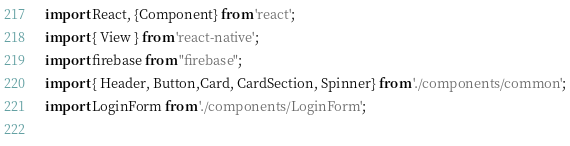<code> <loc_0><loc_0><loc_500><loc_500><_JavaScript_>import React, {Component} from 'react';
import { View } from 'react-native';
import firebase from "firebase";
import { Header, Button,Card, CardSection, Spinner} from './components/common';
import LoginForm from './components/LoginForm';
 
</code> 